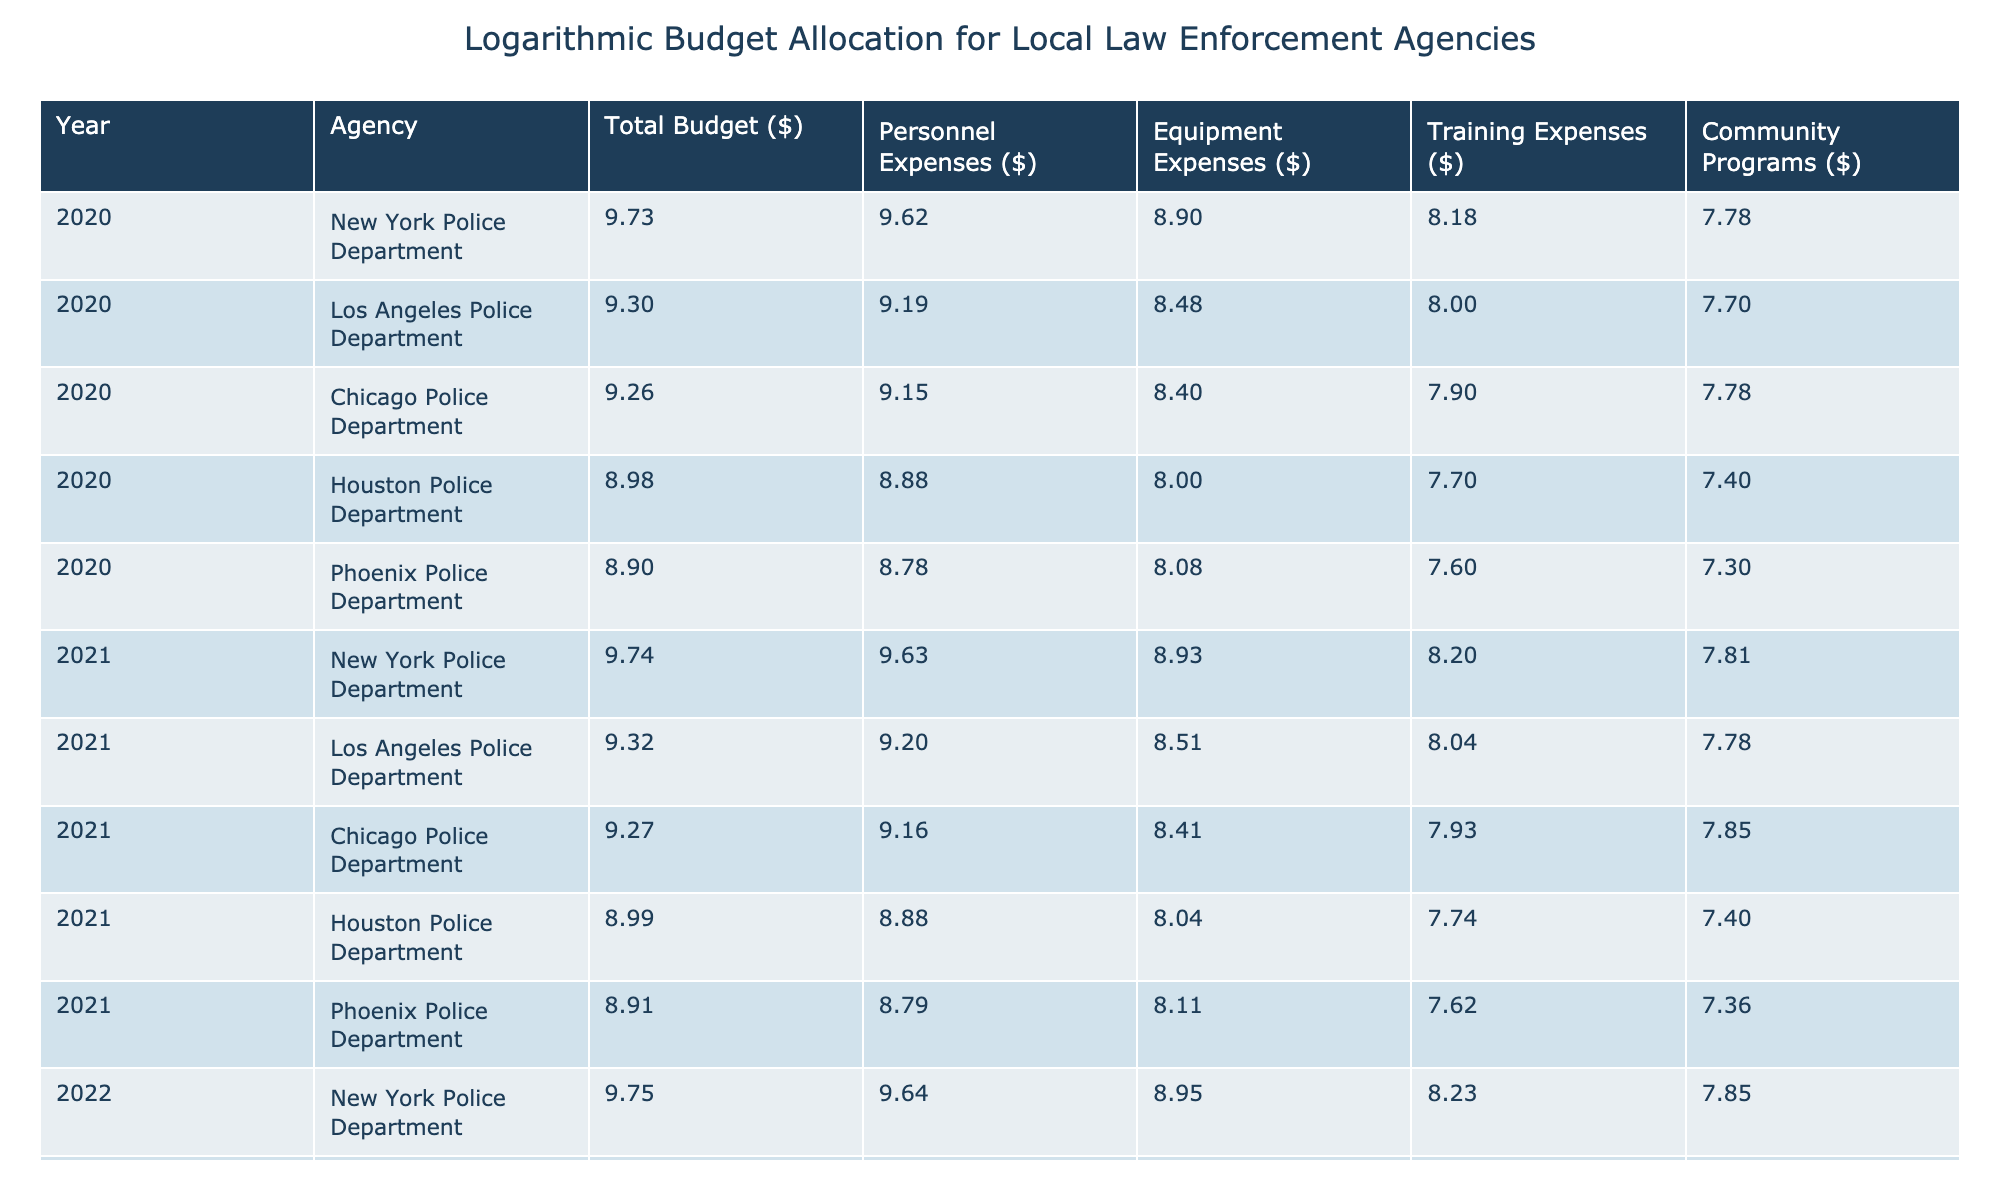What was the total budget for the Los Angeles Police Department in 2020? The table shows that the total budget for the Los Angeles Police Department in 2020 is directly listed under the Total Budget column for that agency and year, which is $2,000,000,000.
Answer: 2,000,000,000 Which agency had the highest personnel expenses in 2022? By looking at the Personnel Expenses column for 2022, we see that the New York Police Department had personnel expenses of $4,400,000,000, which is greater than the expenses of all other listed agencies.
Answer: New York Police Department What is the difference in total budget between the Chicago Police Department in 2021 and 2022? The total budget for the Chicago Police Department in 2021 is $1,850,000,000 and it is $1,900,000,000 in 2022. The difference is calculated by subtracting the 2021 budget from the 2022 budget: $1,900,000,000 - $1,850,000,000 = $50,000,000.
Answer: 50,000,000 Did the total budget for the Phoenix Police Department increase from 2020 to 2021? In 2020, the Phoenix Police Department had a total budget of $800,000,000, and in 2021, it increased to $820,000,000. Since $820,000,000 is greater than $800,000,000, the answer is yes.
Answer: Yes What was the average training expenses across all agencies for the year 2020? To find the average training expenses for 2020, we sum the training expenses for all agencies: $150,000,000 + $100,000,000 + $80,000,000 + $50,000,000 + $40,000,000 = $420,000,000. Dividing by the number of agencies (5), we get an average of $420,000,000 / 5 = $84,000,000.
Answer: 84,000,000 What agency had the lowest community programs budget in 2022? The community programs budget for each agency in 2022 is: $70,000,000 (New York), $65,000,000 (Los Angeles), $75,000,000 (Chicago), $30,000,000 (Houston), $25,000,000 (Phoenix). The lowest amount is found in the Phoenix Police Department.
Answer: Phoenix Police Department By what percentage did the equipment expenses increase for the New York Police Department from 2020 to 2021? The equipment expenses for the New York Police Department in 2020 were $800,000,000, and in 2021, it was $850,000,000. The increase is $850,000,000 - $800,000,000 = $50,000,000. To calculate the percentage increase: ($50,000,000 / $800,000,000) * 100 = 6.25%.
Answer: 6.25% 